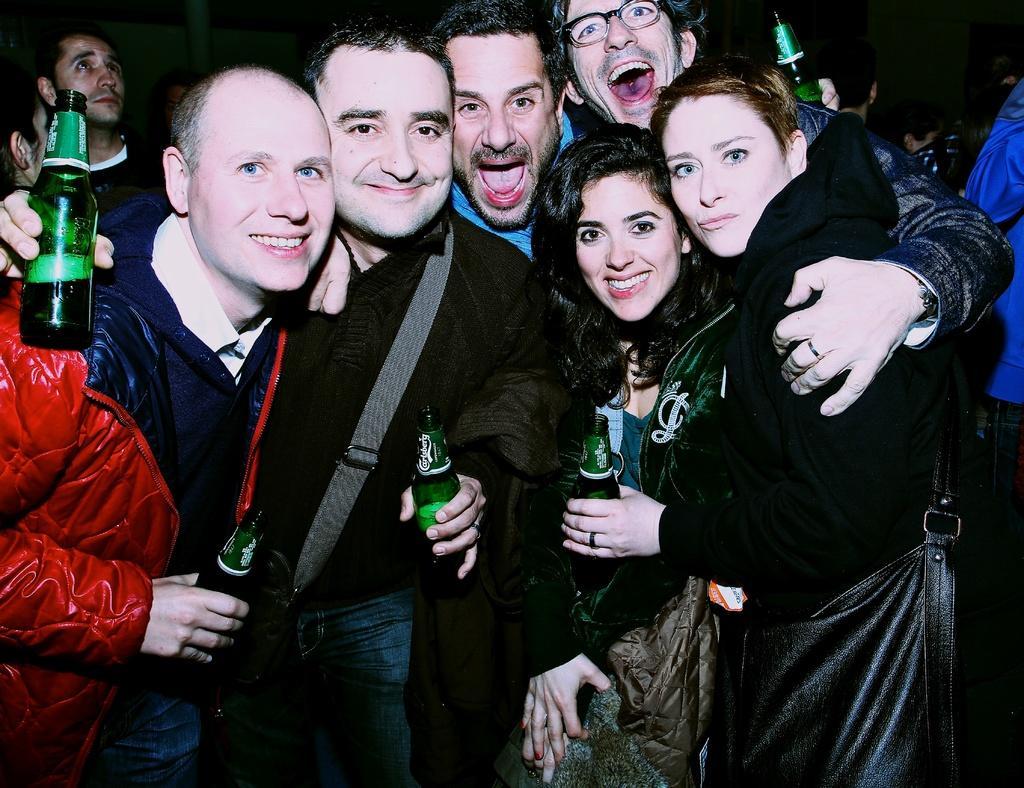How would you summarize this image in a sentence or two? A group of people are standing,smiling and holding wine bottle in their hands. Behind them there are few more people. 